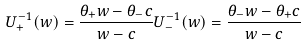Convert formula to latex. <formula><loc_0><loc_0><loc_500><loc_500>U _ { + } ^ { - 1 } ( w ) = \frac { \theta _ { + } w - \theta _ { - } c } { w - c } U _ { - } ^ { - 1 } ( w ) = \frac { \theta _ { - } w - \theta _ { + } c } { w - c }</formula> 